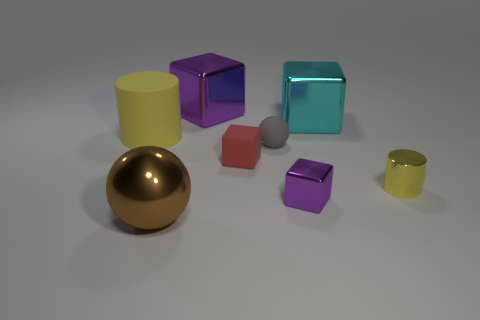There is a object that is in front of the small yellow cylinder and on the left side of the small purple metallic object; what material is it?
Your answer should be very brief. Metal. Are there any small red blocks in front of the yellow thing that is to the right of the big purple cube?
Provide a succinct answer. No. What number of tiny things have the same color as the metallic cylinder?
Your answer should be very brief. 0. There is another object that is the same color as the big rubber object; what material is it?
Your answer should be very brief. Metal. Do the big purple thing and the small gray thing have the same material?
Offer a very short reply. No. There is a big yellow cylinder; are there any large brown metallic spheres behind it?
Your answer should be very brief. No. What is the material of the cylinder that is on the left side of the purple metallic cube on the right side of the red block?
Your response must be concise. Rubber. There is another object that is the same shape as the large rubber object; what is its size?
Offer a very short reply. Small. Does the rubber block have the same color as the shiny cylinder?
Provide a succinct answer. No. What is the color of the large object that is left of the tiny gray thing and right of the metal ball?
Offer a very short reply. Purple. 